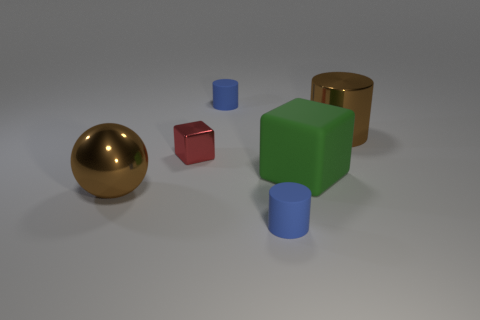Do the tiny red object and the blue thing that is in front of the big brown sphere have the same material?
Make the answer very short. No. Is the number of big cylinders that are to the left of the shiny ball greater than the number of objects to the right of the small red object?
Ensure brevity in your answer.  No. The block that is right of the matte thing behind the big metallic cylinder is what color?
Offer a very short reply. Green. How many cylinders are either purple things or blue things?
Your response must be concise. 2. How many blue objects are both behind the brown shiny cylinder and in front of the brown ball?
Offer a very short reply. 0. There is a block in front of the red block; what is its color?
Your response must be concise. Green. What size is the red cube that is made of the same material as the brown sphere?
Your answer should be compact. Small. There is a object in front of the large ball; how many red things are to the right of it?
Provide a short and direct response. 0. There is a green block; what number of large brown balls are behind it?
Offer a terse response. 0. There is a tiny object that is in front of the brown thing that is on the left side of the cylinder in front of the large brown cylinder; what is its color?
Your answer should be very brief. Blue. 